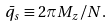Convert formula to latex. <formula><loc_0><loc_0><loc_500><loc_500>\bar { q } _ { s } \equiv 2 \pi M _ { z } / N .</formula> 